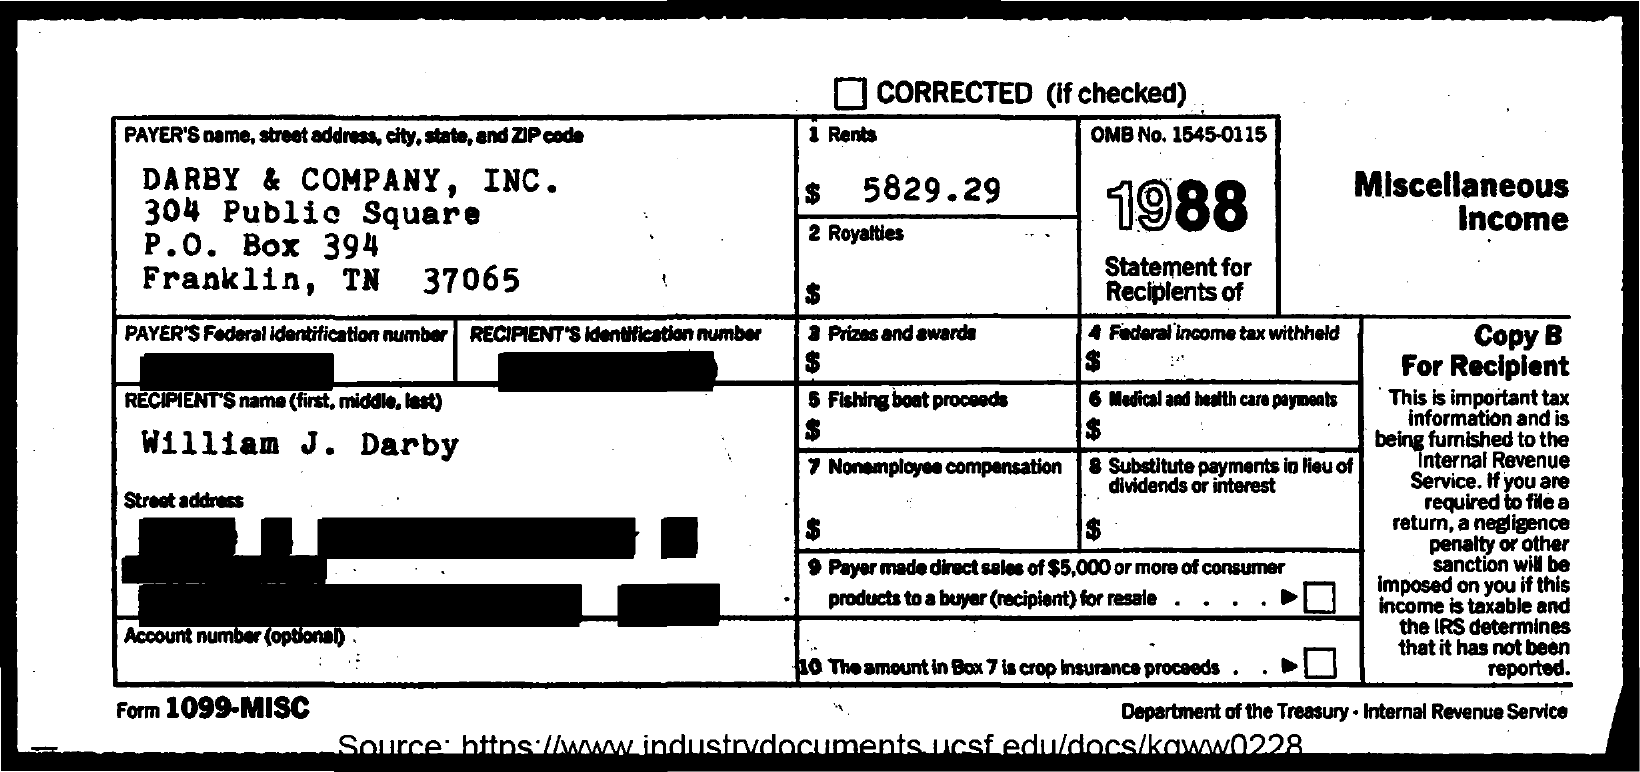Give some essential details in this illustration. The document mentions OMB number 1545-0115. The payer's name mentioned in the document is "DARBY & COMPANY, INC.". The recipient's name mentioned in the document is William J. Darby. 